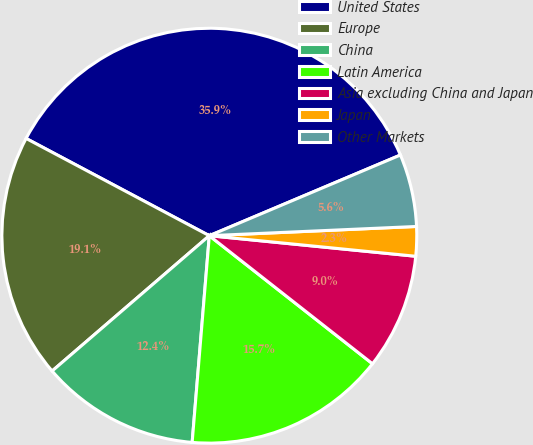Convert chart to OTSL. <chart><loc_0><loc_0><loc_500><loc_500><pie_chart><fcel>United States<fcel>Europe<fcel>China<fcel>Latin America<fcel>Asia excluding China and Japan<fcel>Japan<fcel>Other Markets<nl><fcel>35.88%<fcel>19.08%<fcel>12.37%<fcel>15.73%<fcel>9.01%<fcel>2.29%<fcel>5.65%<nl></chart> 